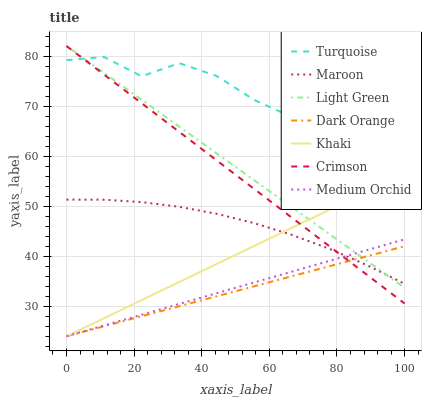Does Khaki have the minimum area under the curve?
Answer yes or no. No. Does Khaki have the maximum area under the curve?
Answer yes or no. No. Is Turquoise the smoothest?
Answer yes or no. No. Is Khaki the roughest?
Answer yes or no. No. Does Turquoise have the lowest value?
Answer yes or no. No. Does Turquoise have the highest value?
Answer yes or no. No. Is Dark Orange less than Turquoise?
Answer yes or no. Yes. Is Turquoise greater than Maroon?
Answer yes or no. Yes. Does Dark Orange intersect Turquoise?
Answer yes or no. No. 